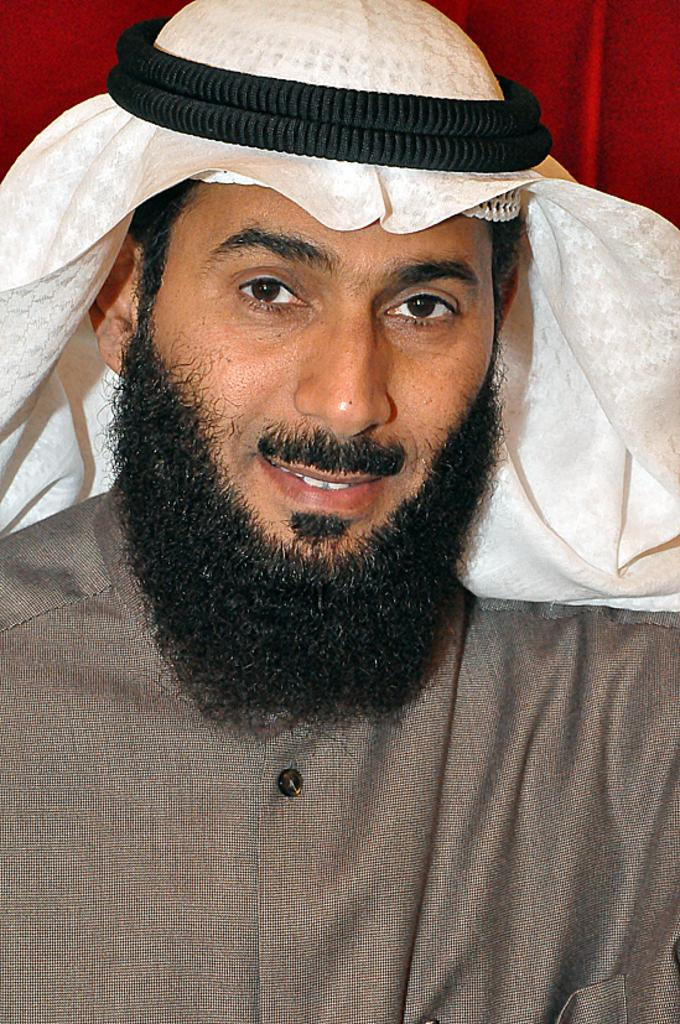What is the main subject in the foreground of the picture? There is a man in the foreground of the picture. Can you describe the man's appearance? The man has a beard and is wearing a turban on his head. What is the man's facial expression? The man is smiling. What can be seen in the background of the picture? There is a red curtain in the background of the picture. What type of produce is the man holding in the picture? There is no produce visible in the picture; the man is not holding anything. How many daughters does the man have in the picture? There is no information about the man's daughters in the picture, as it only shows the man himself. 